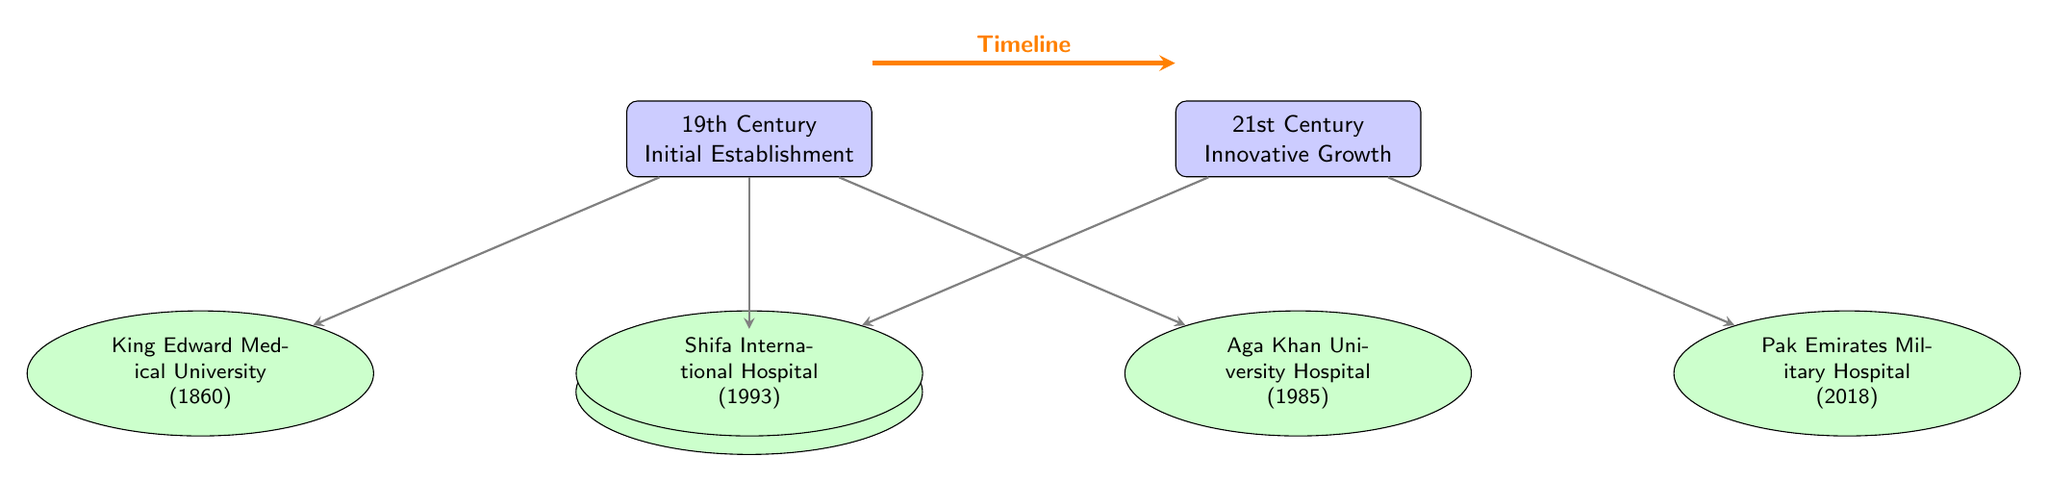What is the first medical university established in Pakistan? The diagram lists King Edward Medical University established in 1860 as the earliest medical institution.
Answer: King Edward Medical University How many major medical institutions are represented in the diagram? By counting the institutions in the diagram, there are a total of five major medical institutions illustrated.
Answer: 5 Which medical institution was founded in 1945? The diagram identifies Dow University of Health Sciences as the institution that was established in 1945.
Answer: Dow University of Health Sciences What is the latest medical institution shown in the timeline? The timeline indicates that Pak Emirates Military Hospital, established in 2018, is the most recent institution listed.
Answer: Pak Emirates Military Hospital What period does the timeline cover? The timeline spans from the 19th century to the 21st century, as indicated by the two timeline nodes at each end.
Answer: 19th Century to 21st Century Which medical institution was founded between the years 1980 and 1990? Among the institutions listed, Aga Khan University Hospital, founded in 1985, falls within this timeframe.
Answer: Aga Khan University Hospital Is there an institution represented that was established in the 21st century? The diagram confirms that Shifa International Hospital, established in 1993, is depicted under the 21st-century category.
Answer: Shifa International Hospital Identify the oldest institution in the diagram. The diagram shows King Edward Medical University, established in 1860, as the oldest institution among those listed.
Answer: King Edward Medical University 